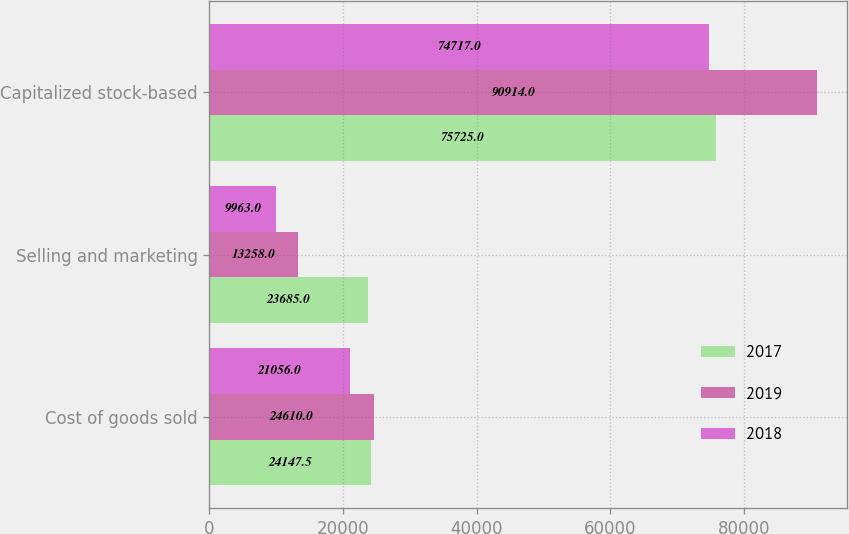Convert chart to OTSL. <chart><loc_0><loc_0><loc_500><loc_500><stacked_bar_chart><ecel><fcel>Cost of goods sold<fcel>Selling and marketing<fcel>Capitalized stock-based<nl><fcel>2017<fcel>24147.5<fcel>23685<fcel>75725<nl><fcel>2019<fcel>24610<fcel>13258<fcel>90914<nl><fcel>2018<fcel>21056<fcel>9963<fcel>74717<nl></chart> 